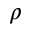Convert formula to latex. <formula><loc_0><loc_0><loc_500><loc_500>\rho</formula> 